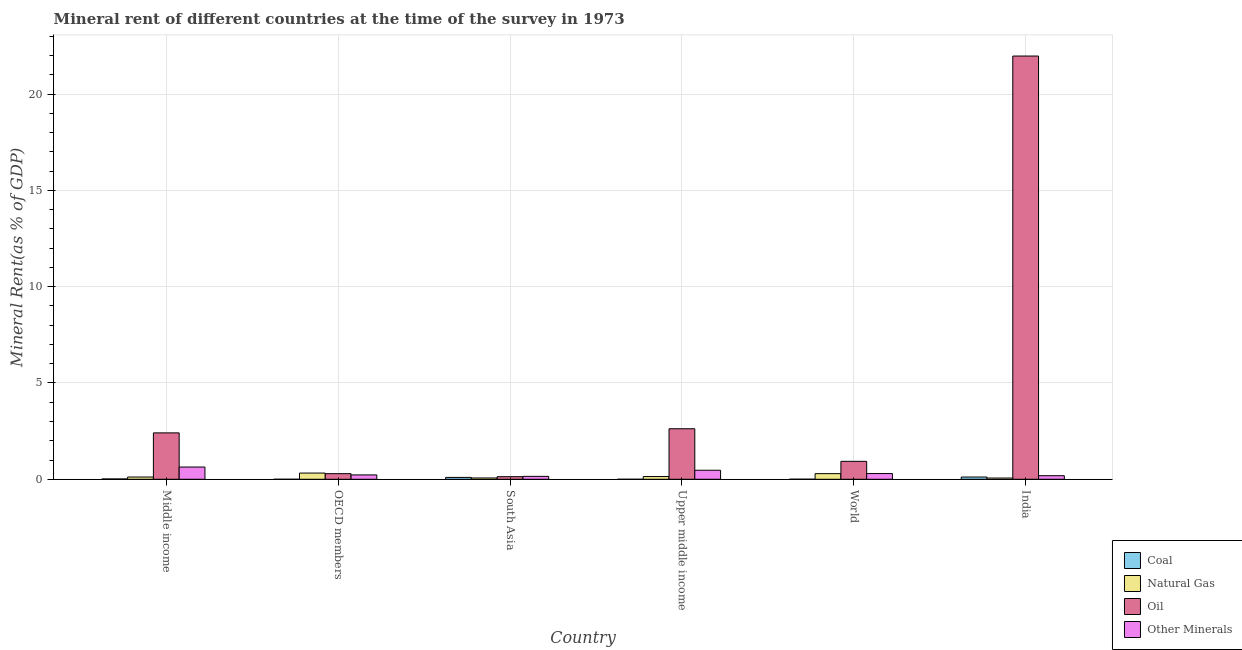How many different coloured bars are there?
Keep it short and to the point. 4. How many bars are there on the 6th tick from the left?
Offer a very short reply. 4. In how many cases, is the number of bars for a given country not equal to the number of legend labels?
Ensure brevity in your answer.  0. What is the oil rent in OECD members?
Your response must be concise. 0.29. Across all countries, what is the maximum oil rent?
Ensure brevity in your answer.  21.98. Across all countries, what is the minimum coal rent?
Your answer should be very brief. 1.50641686702978e-6. In which country was the oil rent minimum?
Offer a very short reply. South Asia. What is the total coal rent in the graph?
Ensure brevity in your answer.  0.23. What is the difference between the coal rent in India and that in World?
Give a very brief answer. 0.11. What is the difference between the  rent of other minerals in Middle income and the coal rent in South Asia?
Provide a succinct answer. 0.54. What is the average coal rent per country?
Make the answer very short. 0.04. What is the difference between the oil rent and natural gas rent in Middle income?
Your response must be concise. 2.29. What is the ratio of the  rent of other minerals in Upper middle income to that in World?
Keep it short and to the point. 1.58. Is the oil rent in South Asia less than that in World?
Ensure brevity in your answer.  Yes. What is the difference between the highest and the second highest oil rent?
Keep it short and to the point. 19.35. What is the difference between the highest and the lowest  rent of other minerals?
Provide a short and direct response. 0.48. Is it the case that in every country, the sum of the natural gas rent and  rent of other minerals is greater than the sum of coal rent and oil rent?
Make the answer very short. No. What does the 2nd bar from the left in India represents?
Your answer should be compact. Natural Gas. What does the 4th bar from the right in South Asia represents?
Your answer should be very brief. Coal. Is it the case that in every country, the sum of the coal rent and natural gas rent is greater than the oil rent?
Ensure brevity in your answer.  No. How many bars are there?
Your answer should be compact. 24. Are all the bars in the graph horizontal?
Keep it short and to the point. No. How many countries are there in the graph?
Your answer should be very brief. 6. Are the values on the major ticks of Y-axis written in scientific E-notation?
Your answer should be very brief. No. Does the graph contain grids?
Your answer should be very brief. Yes. How are the legend labels stacked?
Your response must be concise. Vertical. What is the title of the graph?
Give a very brief answer. Mineral rent of different countries at the time of the survey in 1973. Does "UNHCR" appear as one of the legend labels in the graph?
Offer a very short reply. No. What is the label or title of the X-axis?
Offer a very short reply. Country. What is the label or title of the Y-axis?
Ensure brevity in your answer.  Mineral Rent(as % of GDP). What is the Mineral Rent(as % of GDP) in Coal in Middle income?
Your answer should be very brief. 0.02. What is the Mineral Rent(as % of GDP) in Natural Gas in Middle income?
Your answer should be compact. 0.12. What is the Mineral Rent(as % of GDP) of Oil in Middle income?
Keep it short and to the point. 2.41. What is the Mineral Rent(as % of GDP) in Other Minerals in Middle income?
Make the answer very short. 0.64. What is the Mineral Rent(as % of GDP) in Coal in OECD members?
Provide a succinct answer. 1.50641686702978e-6. What is the Mineral Rent(as % of GDP) of Natural Gas in OECD members?
Provide a succinct answer. 0.32. What is the Mineral Rent(as % of GDP) in Oil in OECD members?
Make the answer very short. 0.29. What is the Mineral Rent(as % of GDP) of Other Minerals in OECD members?
Make the answer very short. 0.23. What is the Mineral Rent(as % of GDP) in Coal in South Asia?
Keep it short and to the point. 0.1. What is the Mineral Rent(as % of GDP) in Natural Gas in South Asia?
Provide a short and direct response. 0.07. What is the Mineral Rent(as % of GDP) in Oil in South Asia?
Your answer should be very brief. 0.14. What is the Mineral Rent(as % of GDP) of Other Minerals in South Asia?
Offer a terse response. 0.15. What is the Mineral Rent(as % of GDP) in Coal in Upper middle income?
Keep it short and to the point. 0. What is the Mineral Rent(as % of GDP) of Natural Gas in Upper middle income?
Offer a very short reply. 0.14. What is the Mineral Rent(as % of GDP) in Oil in Upper middle income?
Your answer should be very brief. 2.62. What is the Mineral Rent(as % of GDP) in Other Minerals in Upper middle income?
Ensure brevity in your answer.  0.47. What is the Mineral Rent(as % of GDP) of Coal in World?
Offer a very short reply. 0. What is the Mineral Rent(as % of GDP) in Natural Gas in World?
Your answer should be very brief. 0.29. What is the Mineral Rent(as % of GDP) of Oil in World?
Provide a succinct answer. 0.93. What is the Mineral Rent(as % of GDP) of Other Minerals in World?
Your response must be concise. 0.3. What is the Mineral Rent(as % of GDP) of Coal in India?
Make the answer very short. 0.12. What is the Mineral Rent(as % of GDP) in Natural Gas in India?
Provide a short and direct response. 0.06. What is the Mineral Rent(as % of GDP) in Oil in India?
Your answer should be very brief. 21.98. What is the Mineral Rent(as % of GDP) in Other Minerals in India?
Your answer should be very brief. 0.19. Across all countries, what is the maximum Mineral Rent(as % of GDP) in Coal?
Keep it short and to the point. 0.12. Across all countries, what is the maximum Mineral Rent(as % of GDP) of Natural Gas?
Provide a succinct answer. 0.32. Across all countries, what is the maximum Mineral Rent(as % of GDP) of Oil?
Your answer should be very brief. 21.98. Across all countries, what is the maximum Mineral Rent(as % of GDP) of Other Minerals?
Your answer should be compact. 0.64. Across all countries, what is the minimum Mineral Rent(as % of GDP) of Coal?
Your response must be concise. 1.50641686702978e-6. Across all countries, what is the minimum Mineral Rent(as % of GDP) in Natural Gas?
Offer a terse response. 0.06. Across all countries, what is the minimum Mineral Rent(as % of GDP) in Oil?
Your answer should be compact. 0.14. Across all countries, what is the minimum Mineral Rent(as % of GDP) of Other Minerals?
Ensure brevity in your answer.  0.15. What is the total Mineral Rent(as % of GDP) in Coal in the graph?
Offer a very short reply. 0.23. What is the total Mineral Rent(as % of GDP) in Natural Gas in the graph?
Your answer should be compact. 1.01. What is the total Mineral Rent(as % of GDP) of Oil in the graph?
Make the answer very short. 28.36. What is the total Mineral Rent(as % of GDP) of Other Minerals in the graph?
Your response must be concise. 1.97. What is the difference between the Mineral Rent(as % of GDP) in Coal in Middle income and that in OECD members?
Give a very brief answer. 0.02. What is the difference between the Mineral Rent(as % of GDP) of Natural Gas in Middle income and that in OECD members?
Your answer should be very brief. -0.2. What is the difference between the Mineral Rent(as % of GDP) of Oil in Middle income and that in OECD members?
Provide a short and direct response. 2.12. What is the difference between the Mineral Rent(as % of GDP) of Other Minerals in Middle income and that in OECD members?
Your response must be concise. 0.41. What is the difference between the Mineral Rent(as % of GDP) in Coal in Middle income and that in South Asia?
Ensure brevity in your answer.  -0.08. What is the difference between the Mineral Rent(as % of GDP) of Natural Gas in Middle income and that in South Asia?
Make the answer very short. 0.05. What is the difference between the Mineral Rent(as % of GDP) of Oil in Middle income and that in South Asia?
Give a very brief answer. 2.27. What is the difference between the Mineral Rent(as % of GDP) in Other Minerals in Middle income and that in South Asia?
Your answer should be compact. 0.48. What is the difference between the Mineral Rent(as % of GDP) of Coal in Middle income and that in Upper middle income?
Offer a very short reply. 0.02. What is the difference between the Mineral Rent(as % of GDP) in Natural Gas in Middle income and that in Upper middle income?
Provide a short and direct response. -0.03. What is the difference between the Mineral Rent(as % of GDP) in Oil in Middle income and that in Upper middle income?
Offer a terse response. -0.21. What is the difference between the Mineral Rent(as % of GDP) in Other Minerals in Middle income and that in Upper middle income?
Your answer should be very brief. 0.17. What is the difference between the Mineral Rent(as % of GDP) in Coal in Middle income and that in World?
Your answer should be compact. 0.01. What is the difference between the Mineral Rent(as % of GDP) of Natural Gas in Middle income and that in World?
Ensure brevity in your answer.  -0.17. What is the difference between the Mineral Rent(as % of GDP) in Oil in Middle income and that in World?
Your answer should be very brief. 1.48. What is the difference between the Mineral Rent(as % of GDP) of Other Minerals in Middle income and that in World?
Ensure brevity in your answer.  0.34. What is the difference between the Mineral Rent(as % of GDP) in Coal in Middle income and that in India?
Your response must be concise. -0.1. What is the difference between the Mineral Rent(as % of GDP) of Natural Gas in Middle income and that in India?
Offer a terse response. 0.05. What is the difference between the Mineral Rent(as % of GDP) of Oil in Middle income and that in India?
Give a very brief answer. -19.57. What is the difference between the Mineral Rent(as % of GDP) in Other Minerals in Middle income and that in India?
Keep it short and to the point. 0.45. What is the difference between the Mineral Rent(as % of GDP) of Coal in OECD members and that in South Asia?
Ensure brevity in your answer.  -0.1. What is the difference between the Mineral Rent(as % of GDP) in Natural Gas in OECD members and that in South Asia?
Ensure brevity in your answer.  0.25. What is the difference between the Mineral Rent(as % of GDP) of Oil in OECD members and that in South Asia?
Your answer should be compact. 0.16. What is the difference between the Mineral Rent(as % of GDP) of Other Minerals in OECD members and that in South Asia?
Provide a succinct answer. 0.08. What is the difference between the Mineral Rent(as % of GDP) in Coal in OECD members and that in Upper middle income?
Offer a terse response. -0. What is the difference between the Mineral Rent(as % of GDP) in Natural Gas in OECD members and that in Upper middle income?
Your answer should be compact. 0.18. What is the difference between the Mineral Rent(as % of GDP) of Oil in OECD members and that in Upper middle income?
Offer a terse response. -2.33. What is the difference between the Mineral Rent(as % of GDP) in Other Minerals in OECD members and that in Upper middle income?
Give a very brief answer. -0.24. What is the difference between the Mineral Rent(as % of GDP) in Coal in OECD members and that in World?
Your answer should be compact. -0. What is the difference between the Mineral Rent(as % of GDP) in Natural Gas in OECD members and that in World?
Your answer should be very brief. 0.03. What is the difference between the Mineral Rent(as % of GDP) in Oil in OECD members and that in World?
Offer a very short reply. -0.64. What is the difference between the Mineral Rent(as % of GDP) in Other Minerals in OECD members and that in World?
Your answer should be compact. -0.07. What is the difference between the Mineral Rent(as % of GDP) of Coal in OECD members and that in India?
Ensure brevity in your answer.  -0.12. What is the difference between the Mineral Rent(as % of GDP) of Natural Gas in OECD members and that in India?
Provide a short and direct response. 0.26. What is the difference between the Mineral Rent(as % of GDP) in Oil in OECD members and that in India?
Ensure brevity in your answer.  -21.68. What is the difference between the Mineral Rent(as % of GDP) of Other Minerals in OECD members and that in India?
Ensure brevity in your answer.  0.04. What is the difference between the Mineral Rent(as % of GDP) in Coal in South Asia and that in Upper middle income?
Your answer should be very brief. 0.1. What is the difference between the Mineral Rent(as % of GDP) of Natural Gas in South Asia and that in Upper middle income?
Ensure brevity in your answer.  -0.07. What is the difference between the Mineral Rent(as % of GDP) of Oil in South Asia and that in Upper middle income?
Give a very brief answer. -2.49. What is the difference between the Mineral Rent(as % of GDP) in Other Minerals in South Asia and that in Upper middle income?
Ensure brevity in your answer.  -0.32. What is the difference between the Mineral Rent(as % of GDP) in Coal in South Asia and that in World?
Your answer should be compact. 0.09. What is the difference between the Mineral Rent(as % of GDP) of Natural Gas in South Asia and that in World?
Give a very brief answer. -0.22. What is the difference between the Mineral Rent(as % of GDP) of Oil in South Asia and that in World?
Provide a succinct answer. -0.8. What is the difference between the Mineral Rent(as % of GDP) in Other Minerals in South Asia and that in World?
Your answer should be very brief. -0.15. What is the difference between the Mineral Rent(as % of GDP) of Coal in South Asia and that in India?
Your answer should be very brief. -0.02. What is the difference between the Mineral Rent(as % of GDP) in Natural Gas in South Asia and that in India?
Your answer should be very brief. 0. What is the difference between the Mineral Rent(as % of GDP) of Oil in South Asia and that in India?
Provide a short and direct response. -21.84. What is the difference between the Mineral Rent(as % of GDP) in Other Minerals in South Asia and that in India?
Your response must be concise. -0.03. What is the difference between the Mineral Rent(as % of GDP) of Coal in Upper middle income and that in World?
Offer a terse response. -0. What is the difference between the Mineral Rent(as % of GDP) in Natural Gas in Upper middle income and that in World?
Offer a terse response. -0.15. What is the difference between the Mineral Rent(as % of GDP) of Oil in Upper middle income and that in World?
Your answer should be compact. 1.69. What is the difference between the Mineral Rent(as % of GDP) of Other Minerals in Upper middle income and that in World?
Provide a short and direct response. 0.17. What is the difference between the Mineral Rent(as % of GDP) in Coal in Upper middle income and that in India?
Offer a terse response. -0.12. What is the difference between the Mineral Rent(as % of GDP) in Natural Gas in Upper middle income and that in India?
Keep it short and to the point. 0.08. What is the difference between the Mineral Rent(as % of GDP) in Oil in Upper middle income and that in India?
Your answer should be compact. -19.35. What is the difference between the Mineral Rent(as % of GDP) in Other Minerals in Upper middle income and that in India?
Offer a terse response. 0.28. What is the difference between the Mineral Rent(as % of GDP) in Coal in World and that in India?
Ensure brevity in your answer.  -0.11. What is the difference between the Mineral Rent(as % of GDP) of Natural Gas in World and that in India?
Offer a terse response. 0.23. What is the difference between the Mineral Rent(as % of GDP) in Oil in World and that in India?
Provide a succinct answer. -21.04. What is the difference between the Mineral Rent(as % of GDP) of Other Minerals in World and that in India?
Your answer should be very brief. 0.11. What is the difference between the Mineral Rent(as % of GDP) of Coal in Middle income and the Mineral Rent(as % of GDP) of Natural Gas in OECD members?
Make the answer very short. -0.31. What is the difference between the Mineral Rent(as % of GDP) in Coal in Middle income and the Mineral Rent(as % of GDP) in Oil in OECD members?
Your answer should be very brief. -0.27. What is the difference between the Mineral Rent(as % of GDP) of Coal in Middle income and the Mineral Rent(as % of GDP) of Other Minerals in OECD members?
Keep it short and to the point. -0.21. What is the difference between the Mineral Rent(as % of GDP) of Natural Gas in Middle income and the Mineral Rent(as % of GDP) of Oil in OECD members?
Your response must be concise. -0.17. What is the difference between the Mineral Rent(as % of GDP) in Natural Gas in Middle income and the Mineral Rent(as % of GDP) in Other Minerals in OECD members?
Provide a succinct answer. -0.11. What is the difference between the Mineral Rent(as % of GDP) of Oil in Middle income and the Mineral Rent(as % of GDP) of Other Minerals in OECD members?
Offer a terse response. 2.18. What is the difference between the Mineral Rent(as % of GDP) of Coal in Middle income and the Mineral Rent(as % of GDP) of Natural Gas in South Asia?
Your answer should be compact. -0.05. What is the difference between the Mineral Rent(as % of GDP) in Coal in Middle income and the Mineral Rent(as % of GDP) in Oil in South Asia?
Ensure brevity in your answer.  -0.12. What is the difference between the Mineral Rent(as % of GDP) in Coal in Middle income and the Mineral Rent(as % of GDP) in Other Minerals in South Asia?
Keep it short and to the point. -0.13. What is the difference between the Mineral Rent(as % of GDP) in Natural Gas in Middle income and the Mineral Rent(as % of GDP) in Oil in South Asia?
Provide a short and direct response. -0.02. What is the difference between the Mineral Rent(as % of GDP) in Natural Gas in Middle income and the Mineral Rent(as % of GDP) in Other Minerals in South Asia?
Your answer should be very brief. -0.03. What is the difference between the Mineral Rent(as % of GDP) in Oil in Middle income and the Mineral Rent(as % of GDP) in Other Minerals in South Asia?
Your answer should be very brief. 2.26. What is the difference between the Mineral Rent(as % of GDP) in Coal in Middle income and the Mineral Rent(as % of GDP) in Natural Gas in Upper middle income?
Your answer should be compact. -0.13. What is the difference between the Mineral Rent(as % of GDP) of Coal in Middle income and the Mineral Rent(as % of GDP) of Oil in Upper middle income?
Provide a succinct answer. -2.61. What is the difference between the Mineral Rent(as % of GDP) of Coal in Middle income and the Mineral Rent(as % of GDP) of Other Minerals in Upper middle income?
Your answer should be compact. -0.45. What is the difference between the Mineral Rent(as % of GDP) in Natural Gas in Middle income and the Mineral Rent(as % of GDP) in Oil in Upper middle income?
Make the answer very short. -2.51. What is the difference between the Mineral Rent(as % of GDP) in Natural Gas in Middle income and the Mineral Rent(as % of GDP) in Other Minerals in Upper middle income?
Give a very brief answer. -0.35. What is the difference between the Mineral Rent(as % of GDP) in Oil in Middle income and the Mineral Rent(as % of GDP) in Other Minerals in Upper middle income?
Your response must be concise. 1.94. What is the difference between the Mineral Rent(as % of GDP) of Coal in Middle income and the Mineral Rent(as % of GDP) of Natural Gas in World?
Provide a short and direct response. -0.27. What is the difference between the Mineral Rent(as % of GDP) in Coal in Middle income and the Mineral Rent(as % of GDP) in Oil in World?
Offer a very short reply. -0.91. What is the difference between the Mineral Rent(as % of GDP) in Coal in Middle income and the Mineral Rent(as % of GDP) in Other Minerals in World?
Ensure brevity in your answer.  -0.28. What is the difference between the Mineral Rent(as % of GDP) in Natural Gas in Middle income and the Mineral Rent(as % of GDP) in Oil in World?
Offer a terse response. -0.81. What is the difference between the Mineral Rent(as % of GDP) in Natural Gas in Middle income and the Mineral Rent(as % of GDP) in Other Minerals in World?
Ensure brevity in your answer.  -0.18. What is the difference between the Mineral Rent(as % of GDP) of Oil in Middle income and the Mineral Rent(as % of GDP) of Other Minerals in World?
Keep it short and to the point. 2.11. What is the difference between the Mineral Rent(as % of GDP) in Coal in Middle income and the Mineral Rent(as % of GDP) in Natural Gas in India?
Provide a short and direct response. -0.05. What is the difference between the Mineral Rent(as % of GDP) of Coal in Middle income and the Mineral Rent(as % of GDP) of Oil in India?
Ensure brevity in your answer.  -21.96. What is the difference between the Mineral Rent(as % of GDP) in Coal in Middle income and the Mineral Rent(as % of GDP) in Other Minerals in India?
Offer a terse response. -0.17. What is the difference between the Mineral Rent(as % of GDP) of Natural Gas in Middle income and the Mineral Rent(as % of GDP) of Oil in India?
Keep it short and to the point. -21.86. What is the difference between the Mineral Rent(as % of GDP) in Natural Gas in Middle income and the Mineral Rent(as % of GDP) in Other Minerals in India?
Your response must be concise. -0.07. What is the difference between the Mineral Rent(as % of GDP) in Oil in Middle income and the Mineral Rent(as % of GDP) in Other Minerals in India?
Your answer should be compact. 2.22. What is the difference between the Mineral Rent(as % of GDP) of Coal in OECD members and the Mineral Rent(as % of GDP) of Natural Gas in South Asia?
Make the answer very short. -0.07. What is the difference between the Mineral Rent(as % of GDP) of Coal in OECD members and the Mineral Rent(as % of GDP) of Oil in South Asia?
Keep it short and to the point. -0.14. What is the difference between the Mineral Rent(as % of GDP) in Coal in OECD members and the Mineral Rent(as % of GDP) in Other Minerals in South Asia?
Your answer should be compact. -0.15. What is the difference between the Mineral Rent(as % of GDP) of Natural Gas in OECD members and the Mineral Rent(as % of GDP) of Oil in South Asia?
Provide a short and direct response. 0.19. What is the difference between the Mineral Rent(as % of GDP) of Natural Gas in OECD members and the Mineral Rent(as % of GDP) of Other Minerals in South Asia?
Your response must be concise. 0.17. What is the difference between the Mineral Rent(as % of GDP) in Oil in OECD members and the Mineral Rent(as % of GDP) in Other Minerals in South Asia?
Your answer should be compact. 0.14. What is the difference between the Mineral Rent(as % of GDP) in Coal in OECD members and the Mineral Rent(as % of GDP) in Natural Gas in Upper middle income?
Ensure brevity in your answer.  -0.14. What is the difference between the Mineral Rent(as % of GDP) in Coal in OECD members and the Mineral Rent(as % of GDP) in Oil in Upper middle income?
Your answer should be very brief. -2.62. What is the difference between the Mineral Rent(as % of GDP) of Coal in OECD members and the Mineral Rent(as % of GDP) of Other Minerals in Upper middle income?
Offer a terse response. -0.47. What is the difference between the Mineral Rent(as % of GDP) in Natural Gas in OECD members and the Mineral Rent(as % of GDP) in Oil in Upper middle income?
Provide a succinct answer. -2.3. What is the difference between the Mineral Rent(as % of GDP) in Natural Gas in OECD members and the Mineral Rent(as % of GDP) in Other Minerals in Upper middle income?
Your response must be concise. -0.15. What is the difference between the Mineral Rent(as % of GDP) in Oil in OECD members and the Mineral Rent(as % of GDP) in Other Minerals in Upper middle income?
Your response must be concise. -0.18. What is the difference between the Mineral Rent(as % of GDP) of Coal in OECD members and the Mineral Rent(as % of GDP) of Natural Gas in World?
Offer a terse response. -0.29. What is the difference between the Mineral Rent(as % of GDP) in Coal in OECD members and the Mineral Rent(as % of GDP) in Oil in World?
Offer a terse response. -0.93. What is the difference between the Mineral Rent(as % of GDP) of Coal in OECD members and the Mineral Rent(as % of GDP) of Other Minerals in World?
Offer a very short reply. -0.3. What is the difference between the Mineral Rent(as % of GDP) of Natural Gas in OECD members and the Mineral Rent(as % of GDP) of Oil in World?
Keep it short and to the point. -0.61. What is the difference between the Mineral Rent(as % of GDP) of Natural Gas in OECD members and the Mineral Rent(as % of GDP) of Other Minerals in World?
Your answer should be compact. 0.03. What is the difference between the Mineral Rent(as % of GDP) in Oil in OECD members and the Mineral Rent(as % of GDP) in Other Minerals in World?
Offer a terse response. -0.01. What is the difference between the Mineral Rent(as % of GDP) in Coal in OECD members and the Mineral Rent(as % of GDP) in Natural Gas in India?
Offer a terse response. -0.06. What is the difference between the Mineral Rent(as % of GDP) in Coal in OECD members and the Mineral Rent(as % of GDP) in Oil in India?
Give a very brief answer. -21.98. What is the difference between the Mineral Rent(as % of GDP) of Coal in OECD members and the Mineral Rent(as % of GDP) of Other Minerals in India?
Provide a succinct answer. -0.19. What is the difference between the Mineral Rent(as % of GDP) of Natural Gas in OECD members and the Mineral Rent(as % of GDP) of Oil in India?
Make the answer very short. -21.65. What is the difference between the Mineral Rent(as % of GDP) of Natural Gas in OECD members and the Mineral Rent(as % of GDP) of Other Minerals in India?
Offer a very short reply. 0.14. What is the difference between the Mineral Rent(as % of GDP) of Oil in OECD members and the Mineral Rent(as % of GDP) of Other Minerals in India?
Provide a short and direct response. 0.11. What is the difference between the Mineral Rent(as % of GDP) of Coal in South Asia and the Mineral Rent(as % of GDP) of Natural Gas in Upper middle income?
Make the answer very short. -0.05. What is the difference between the Mineral Rent(as % of GDP) of Coal in South Asia and the Mineral Rent(as % of GDP) of Oil in Upper middle income?
Make the answer very short. -2.53. What is the difference between the Mineral Rent(as % of GDP) in Coal in South Asia and the Mineral Rent(as % of GDP) in Other Minerals in Upper middle income?
Provide a succinct answer. -0.37. What is the difference between the Mineral Rent(as % of GDP) in Natural Gas in South Asia and the Mineral Rent(as % of GDP) in Oil in Upper middle income?
Provide a short and direct response. -2.55. What is the difference between the Mineral Rent(as % of GDP) of Natural Gas in South Asia and the Mineral Rent(as % of GDP) of Other Minerals in Upper middle income?
Offer a very short reply. -0.4. What is the difference between the Mineral Rent(as % of GDP) in Oil in South Asia and the Mineral Rent(as % of GDP) in Other Minerals in Upper middle income?
Offer a terse response. -0.33. What is the difference between the Mineral Rent(as % of GDP) of Coal in South Asia and the Mineral Rent(as % of GDP) of Natural Gas in World?
Make the answer very short. -0.2. What is the difference between the Mineral Rent(as % of GDP) of Coal in South Asia and the Mineral Rent(as % of GDP) of Oil in World?
Make the answer very short. -0.83. What is the difference between the Mineral Rent(as % of GDP) in Coal in South Asia and the Mineral Rent(as % of GDP) in Other Minerals in World?
Your answer should be compact. -0.2. What is the difference between the Mineral Rent(as % of GDP) in Natural Gas in South Asia and the Mineral Rent(as % of GDP) in Oil in World?
Ensure brevity in your answer.  -0.86. What is the difference between the Mineral Rent(as % of GDP) in Natural Gas in South Asia and the Mineral Rent(as % of GDP) in Other Minerals in World?
Keep it short and to the point. -0.23. What is the difference between the Mineral Rent(as % of GDP) of Oil in South Asia and the Mineral Rent(as % of GDP) of Other Minerals in World?
Offer a terse response. -0.16. What is the difference between the Mineral Rent(as % of GDP) of Coal in South Asia and the Mineral Rent(as % of GDP) of Natural Gas in India?
Provide a succinct answer. 0.03. What is the difference between the Mineral Rent(as % of GDP) in Coal in South Asia and the Mineral Rent(as % of GDP) in Oil in India?
Provide a short and direct response. -21.88. What is the difference between the Mineral Rent(as % of GDP) of Coal in South Asia and the Mineral Rent(as % of GDP) of Other Minerals in India?
Keep it short and to the point. -0.09. What is the difference between the Mineral Rent(as % of GDP) of Natural Gas in South Asia and the Mineral Rent(as % of GDP) of Oil in India?
Make the answer very short. -21.91. What is the difference between the Mineral Rent(as % of GDP) of Natural Gas in South Asia and the Mineral Rent(as % of GDP) of Other Minerals in India?
Your answer should be very brief. -0.12. What is the difference between the Mineral Rent(as % of GDP) of Oil in South Asia and the Mineral Rent(as % of GDP) of Other Minerals in India?
Ensure brevity in your answer.  -0.05. What is the difference between the Mineral Rent(as % of GDP) of Coal in Upper middle income and the Mineral Rent(as % of GDP) of Natural Gas in World?
Give a very brief answer. -0.29. What is the difference between the Mineral Rent(as % of GDP) of Coal in Upper middle income and the Mineral Rent(as % of GDP) of Oil in World?
Offer a very short reply. -0.93. What is the difference between the Mineral Rent(as % of GDP) of Coal in Upper middle income and the Mineral Rent(as % of GDP) of Other Minerals in World?
Keep it short and to the point. -0.3. What is the difference between the Mineral Rent(as % of GDP) of Natural Gas in Upper middle income and the Mineral Rent(as % of GDP) of Oil in World?
Your response must be concise. -0.79. What is the difference between the Mineral Rent(as % of GDP) of Natural Gas in Upper middle income and the Mineral Rent(as % of GDP) of Other Minerals in World?
Make the answer very short. -0.15. What is the difference between the Mineral Rent(as % of GDP) of Oil in Upper middle income and the Mineral Rent(as % of GDP) of Other Minerals in World?
Offer a terse response. 2.33. What is the difference between the Mineral Rent(as % of GDP) in Coal in Upper middle income and the Mineral Rent(as % of GDP) in Natural Gas in India?
Offer a very short reply. -0.06. What is the difference between the Mineral Rent(as % of GDP) of Coal in Upper middle income and the Mineral Rent(as % of GDP) of Oil in India?
Your answer should be compact. -21.97. What is the difference between the Mineral Rent(as % of GDP) in Coal in Upper middle income and the Mineral Rent(as % of GDP) in Other Minerals in India?
Your response must be concise. -0.19. What is the difference between the Mineral Rent(as % of GDP) of Natural Gas in Upper middle income and the Mineral Rent(as % of GDP) of Oil in India?
Your answer should be very brief. -21.83. What is the difference between the Mineral Rent(as % of GDP) of Natural Gas in Upper middle income and the Mineral Rent(as % of GDP) of Other Minerals in India?
Your answer should be compact. -0.04. What is the difference between the Mineral Rent(as % of GDP) in Oil in Upper middle income and the Mineral Rent(as % of GDP) in Other Minerals in India?
Your answer should be compact. 2.44. What is the difference between the Mineral Rent(as % of GDP) in Coal in World and the Mineral Rent(as % of GDP) in Natural Gas in India?
Your answer should be very brief. -0.06. What is the difference between the Mineral Rent(as % of GDP) in Coal in World and the Mineral Rent(as % of GDP) in Oil in India?
Provide a succinct answer. -21.97. What is the difference between the Mineral Rent(as % of GDP) in Coal in World and the Mineral Rent(as % of GDP) in Other Minerals in India?
Offer a terse response. -0.18. What is the difference between the Mineral Rent(as % of GDP) of Natural Gas in World and the Mineral Rent(as % of GDP) of Oil in India?
Offer a terse response. -21.68. What is the difference between the Mineral Rent(as % of GDP) of Natural Gas in World and the Mineral Rent(as % of GDP) of Other Minerals in India?
Your response must be concise. 0.11. What is the difference between the Mineral Rent(as % of GDP) of Oil in World and the Mineral Rent(as % of GDP) of Other Minerals in India?
Provide a short and direct response. 0.75. What is the average Mineral Rent(as % of GDP) in Coal per country?
Provide a short and direct response. 0.04. What is the average Mineral Rent(as % of GDP) of Natural Gas per country?
Your answer should be very brief. 0.17. What is the average Mineral Rent(as % of GDP) in Oil per country?
Your response must be concise. 4.73. What is the average Mineral Rent(as % of GDP) in Other Minerals per country?
Give a very brief answer. 0.33. What is the difference between the Mineral Rent(as % of GDP) of Coal and Mineral Rent(as % of GDP) of Natural Gas in Middle income?
Keep it short and to the point. -0.1. What is the difference between the Mineral Rent(as % of GDP) in Coal and Mineral Rent(as % of GDP) in Oil in Middle income?
Provide a short and direct response. -2.39. What is the difference between the Mineral Rent(as % of GDP) in Coal and Mineral Rent(as % of GDP) in Other Minerals in Middle income?
Your answer should be compact. -0.62. What is the difference between the Mineral Rent(as % of GDP) in Natural Gas and Mineral Rent(as % of GDP) in Oil in Middle income?
Offer a terse response. -2.29. What is the difference between the Mineral Rent(as % of GDP) of Natural Gas and Mineral Rent(as % of GDP) of Other Minerals in Middle income?
Your response must be concise. -0.52. What is the difference between the Mineral Rent(as % of GDP) of Oil and Mineral Rent(as % of GDP) of Other Minerals in Middle income?
Give a very brief answer. 1.77. What is the difference between the Mineral Rent(as % of GDP) of Coal and Mineral Rent(as % of GDP) of Natural Gas in OECD members?
Your response must be concise. -0.32. What is the difference between the Mineral Rent(as % of GDP) in Coal and Mineral Rent(as % of GDP) in Oil in OECD members?
Provide a short and direct response. -0.29. What is the difference between the Mineral Rent(as % of GDP) of Coal and Mineral Rent(as % of GDP) of Other Minerals in OECD members?
Keep it short and to the point. -0.23. What is the difference between the Mineral Rent(as % of GDP) in Natural Gas and Mineral Rent(as % of GDP) in Oil in OECD members?
Your answer should be very brief. 0.03. What is the difference between the Mineral Rent(as % of GDP) in Natural Gas and Mineral Rent(as % of GDP) in Other Minerals in OECD members?
Your answer should be very brief. 0.1. What is the difference between the Mineral Rent(as % of GDP) of Oil and Mineral Rent(as % of GDP) of Other Minerals in OECD members?
Provide a succinct answer. 0.07. What is the difference between the Mineral Rent(as % of GDP) of Coal and Mineral Rent(as % of GDP) of Natural Gas in South Asia?
Provide a succinct answer. 0.03. What is the difference between the Mineral Rent(as % of GDP) in Coal and Mineral Rent(as % of GDP) in Oil in South Asia?
Provide a succinct answer. -0.04. What is the difference between the Mineral Rent(as % of GDP) of Coal and Mineral Rent(as % of GDP) of Other Minerals in South Asia?
Ensure brevity in your answer.  -0.05. What is the difference between the Mineral Rent(as % of GDP) in Natural Gas and Mineral Rent(as % of GDP) in Oil in South Asia?
Keep it short and to the point. -0.07. What is the difference between the Mineral Rent(as % of GDP) in Natural Gas and Mineral Rent(as % of GDP) in Other Minerals in South Asia?
Provide a succinct answer. -0.08. What is the difference between the Mineral Rent(as % of GDP) of Oil and Mineral Rent(as % of GDP) of Other Minerals in South Asia?
Give a very brief answer. -0.02. What is the difference between the Mineral Rent(as % of GDP) in Coal and Mineral Rent(as % of GDP) in Natural Gas in Upper middle income?
Your answer should be compact. -0.14. What is the difference between the Mineral Rent(as % of GDP) of Coal and Mineral Rent(as % of GDP) of Oil in Upper middle income?
Keep it short and to the point. -2.62. What is the difference between the Mineral Rent(as % of GDP) of Coal and Mineral Rent(as % of GDP) of Other Minerals in Upper middle income?
Your answer should be compact. -0.47. What is the difference between the Mineral Rent(as % of GDP) of Natural Gas and Mineral Rent(as % of GDP) of Oil in Upper middle income?
Ensure brevity in your answer.  -2.48. What is the difference between the Mineral Rent(as % of GDP) in Natural Gas and Mineral Rent(as % of GDP) in Other Minerals in Upper middle income?
Offer a very short reply. -0.33. What is the difference between the Mineral Rent(as % of GDP) of Oil and Mineral Rent(as % of GDP) of Other Minerals in Upper middle income?
Your answer should be very brief. 2.15. What is the difference between the Mineral Rent(as % of GDP) of Coal and Mineral Rent(as % of GDP) of Natural Gas in World?
Make the answer very short. -0.29. What is the difference between the Mineral Rent(as % of GDP) of Coal and Mineral Rent(as % of GDP) of Oil in World?
Your response must be concise. -0.93. What is the difference between the Mineral Rent(as % of GDP) in Coal and Mineral Rent(as % of GDP) in Other Minerals in World?
Offer a very short reply. -0.29. What is the difference between the Mineral Rent(as % of GDP) in Natural Gas and Mineral Rent(as % of GDP) in Oil in World?
Your response must be concise. -0.64. What is the difference between the Mineral Rent(as % of GDP) of Natural Gas and Mineral Rent(as % of GDP) of Other Minerals in World?
Offer a very short reply. -0.01. What is the difference between the Mineral Rent(as % of GDP) of Oil and Mineral Rent(as % of GDP) of Other Minerals in World?
Give a very brief answer. 0.63. What is the difference between the Mineral Rent(as % of GDP) in Coal and Mineral Rent(as % of GDP) in Natural Gas in India?
Provide a succinct answer. 0.05. What is the difference between the Mineral Rent(as % of GDP) of Coal and Mineral Rent(as % of GDP) of Oil in India?
Provide a succinct answer. -21.86. What is the difference between the Mineral Rent(as % of GDP) of Coal and Mineral Rent(as % of GDP) of Other Minerals in India?
Give a very brief answer. -0.07. What is the difference between the Mineral Rent(as % of GDP) in Natural Gas and Mineral Rent(as % of GDP) in Oil in India?
Offer a terse response. -21.91. What is the difference between the Mineral Rent(as % of GDP) in Natural Gas and Mineral Rent(as % of GDP) in Other Minerals in India?
Keep it short and to the point. -0.12. What is the difference between the Mineral Rent(as % of GDP) in Oil and Mineral Rent(as % of GDP) in Other Minerals in India?
Offer a terse response. 21.79. What is the ratio of the Mineral Rent(as % of GDP) of Coal in Middle income to that in OECD members?
Your answer should be very brief. 1.12e+04. What is the ratio of the Mineral Rent(as % of GDP) of Natural Gas in Middle income to that in OECD members?
Provide a short and direct response. 0.36. What is the ratio of the Mineral Rent(as % of GDP) of Oil in Middle income to that in OECD members?
Give a very brief answer. 8.26. What is the ratio of the Mineral Rent(as % of GDP) in Other Minerals in Middle income to that in OECD members?
Ensure brevity in your answer.  2.81. What is the ratio of the Mineral Rent(as % of GDP) in Coal in Middle income to that in South Asia?
Your answer should be compact. 0.17. What is the ratio of the Mineral Rent(as % of GDP) in Natural Gas in Middle income to that in South Asia?
Your answer should be compact. 1.72. What is the ratio of the Mineral Rent(as % of GDP) in Oil in Middle income to that in South Asia?
Keep it short and to the point. 17.84. What is the ratio of the Mineral Rent(as % of GDP) of Other Minerals in Middle income to that in South Asia?
Make the answer very short. 4.21. What is the ratio of the Mineral Rent(as % of GDP) of Coal in Middle income to that in Upper middle income?
Make the answer very short. 39.04. What is the ratio of the Mineral Rent(as % of GDP) of Natural Gas in Middle income to that in Upper middle income?
Ensure brevity in your answer.  0.82. What is the ratio of the Mineral Rent(as % of GDP) in Oil in Middle income to that in Upper middle income?
Offer a terse response. 0.92. What is the ratio of the Mineral Rent(as % of GDP) of Other Minerals in Middle income to that in Upper middle income?
Give a very brief answer. 1.36. What is the ratio of the Mineral Rent(as % of GDP) of Coal in Middle income to that in World?
Provide a succinct answer. 6.91. What is the ratio of the Mineral Rent(as % of GDP) of Natural Gas in Middle income to that in World?
Provide a succinct answer. 0.4. What is the ratio of the Mineral Rent(as % of GDP) of Oil in Middle income to that in World?
Offer a very short reply. 2.59. What is the ratio of the Mineral Rent(as % of GDP) in Other Minerals in Middle income to that in World?
Offer a very short reply. 2.14. What is the ratio of the Mineral Rent(as % of GDP) in Coal in Middle income to that in India?
Your response must be concise. 0.14. What is the ratio of the Mineral Rent(as % of GDP) in Natural Gas in Middle income to that in India?
Offer a terse response. 1.83. What is the ratio of the Mineral Rent(as % of GDP) of Oil in Middle income to that in India?
Keep it short and to the point. 0.11. What is the ratio of the Mineral Rent(as % of GDP) in Other Minerals in Middle income to that in India?
Ensure brevity in your answer.  3.42. What is the ratio of the Mineral Rent(as % of GDP) in Coal in OECD members to that in South Asia?
Provide a short and direct response. 0. What is the ratio of the Mineral Rent(as % of GDP) of Natural Gas in OECD members to that in South Asia?
Ensure brevity in your answer.  4.73. What is the ratio of the Mineral Rent(as % of GDP) in Oil in OECD members to that in South Asia?
Your response must be concise. 2.16. What is the ratio of the Mineral Rent(as % of GDP) of Other Minerals in OECD members to that in South Asia?
Make the answer very short. 1.5. What is the ratio of the Mineral Rent(as % of GDP) of Coal in OECD members to that in Upper middle income?
Keep it short and to the point. 0. What is the ratio of the Mineral Rent(as % of GDP) in Natural Gas in OECD members to that in Upper middle income?
Offer a very short reply. 2.26. What is the ratio of the Mineral Rent(as % of GDP) of Oil in OECD members to that in Upper middle income?
Ensure brevity in your answer.  0.11. What is the ratio of the Mineral Rent(as % of GDP) of Other Minerals in OECD members to that in Upper middle income?
Your answer should be very brief. 0.48. What is the ratio of the Mineral Rent(as % of GDP) in Coal in OECD members to that in World?
Provide a succinct answer. 0. What is the ratio of the Mineral Rent(as % of GDP) in Natural Gas in OECD members to that in World?
Give a very brief answer. 1.1. What is the ratio of the Mineral Rent(as % of GDP) in Oil in OECD members to that in World?
Your answer should be very brief. 0.31. What is the ratio of the Mineral Rent(as % of GDP) of Other Minerals in OECD members to that in World?
Ensure brevity in your answer.  0.76. What is the ratio of the Mineral Rent(as % of GDP) in Natural Gas in OECD members to that in India?
Ensure brevity in your answer.  5.02. What is the ratio of the Mineral Rent(as % of GDP) in Oil in OECD members to that in India?
Make the answer very short. 0.01. What is the ratio of the Mineral Rent(as % of GDP) of Other Minerals in OECD members to that in India?
Your answer should be compact. 1.22. What is the ratio of the Mineral Rent(as % of GDP) in Coal in South Asia to that in Upper middle income?
Keep it short and to the point. 224.18. What is the ratio of the Mineral Rent(as % of GDP) of Natural Gas in South Asia to that in Upper middle income?
Keep it short and to the point. 0.48. What is the ratio of the Mineral Rent(as % of GDP) of Oil in South Asia to that in Upper middle income?
Your response must be concise. 0.05. What is the ratio of the Mineral Rent(as % of GDP) in Other Minerals in South Asia to that in Upper middle income?
Ensure brevity in your answer.  0.32. What is the ratio of the Mineral Rent(as % of GDP) of Coal in South Asia to that in World?
Your answer should be compact. 39.65. What is the ratio of the Mineral Rent(as % of GDP) of Natural Gas in South Asia to that in World?
Ensure brevity in your answer.  0.23. What is the ratio of the Mineral Rent(as % of GDP) of Oil in South Asia to that in World?
Offer a very short reply. 0.14. What is the ratio of the Mineral Rent(as % of GDP) of Other Minerals in South Asia to that in World?
Ensure brevity in your answer.  0.51. What is the ratio of the Mineral Rent(as % of GDP) in Coal in South Asia to that in India?
Keep it short and to the point. 0.82. What is the ratio of the Mineral Rent(as % of GDP) in Natural Gas in South Asia to that in India?
Make the answer very short. 1.06. What is the ratio of the Mineral Rent(as % of GDP) in Oil in South Asia to that in India?
Offer a terse response. 0.01. What is the ratio of the Mineral Rent(as % of GDP) in Other Minerals in South Asia to that in India?
Your answer should be very brief. 0.81. What is the ratio of the Mineral Rent(as % of GDP) in Coal in Upper middle income to that in World?
Give a very brief answer. 0.18. What is the ratio of the Mineral Rent(as % of GDP) in Natural Gas in Upper middle income to that in World?
Make the answer very short. 0.49. What is the ratio of the Mineral Rent(as % of GDP) of Oil in Upper middle income to that in World?
Provide a succinct answer. 2.82. What is the ratio of the Mineral Rent(as % of GDP) of Other Minerals in Upper middle income to that in World?
Provide a short and direct response. 1.58. What is the ratio of the Mineral Rent(as % of GDP) in Coal in Upper middle income to that in India?
Offer a very short reply. 0. What is the ratio of the Mineral Rent(as % of GDP) in Natural Gas in Upper middle income to that in India?
Provide a succinct answer. 2.22. What is the ratio of the Mineral Rent(as % of GDP) in Oil in Upper middle income to that in India?
Ensure brevity in your answer.  0.12. What is the ratio of the Mineral Rent(as % of GDP) of Other Minerals in Upper middle income to that in India?
Provide a short and direct response. 2.52. What is the ratio of the Mineral Rent(as % of GDP) in Coal in World to that in India?
Make the answer very short. 0.02. What is the ratio of the Mineral Rent(as % of GDP) in Natural Gas in World to that in India?
Give a very brief answer. 4.55. What is the ratio of the Mineral Rent(as % of GDP) in Oil in World to that in India?
Give a very brief answer. 0.04. What is the ratio of the Mineral Rent(as % of GDP) of Other Minerals in World to that in India?
Provide a short and direct response. 1.6. What is the difference between the highest and the second highest Mineral Rent(as % of GDP) of Coal?
Give a very brief answer. 0.02. What is the difference between the highest and the second highest Mineral Rent(as % of GDP) of Natural Gas?
Keep it short and to the point. 0.03. What is the difference between the highest and the second highest Mineral Rent(as % of GDP) in Oil?
Offer a terse response. 19.35. What is the difference between the highest and the second highest Mineral Rent(as % of GDP) in Other Minerals?
Offer a very short reply. 0.17. What is the difference between the highest and the lowest Mineral Rent(as % of GDP) in Coal?
Provide a succinct answer. 0.12. What is the difference between the highest and the lowest Mineral Rent(as % of GDP) of Natural Gas?
Make the answer very short. 0.26. What is the difference between the highest and the lowest Mineral Rent(as % of GDP) in Oil?
Provide a short and direct response. 21.84. What is the difference between the highest and the lowest Mineral Rent(as % of GDP) in Other Minerals?
Make the answer very short. 0.48. 